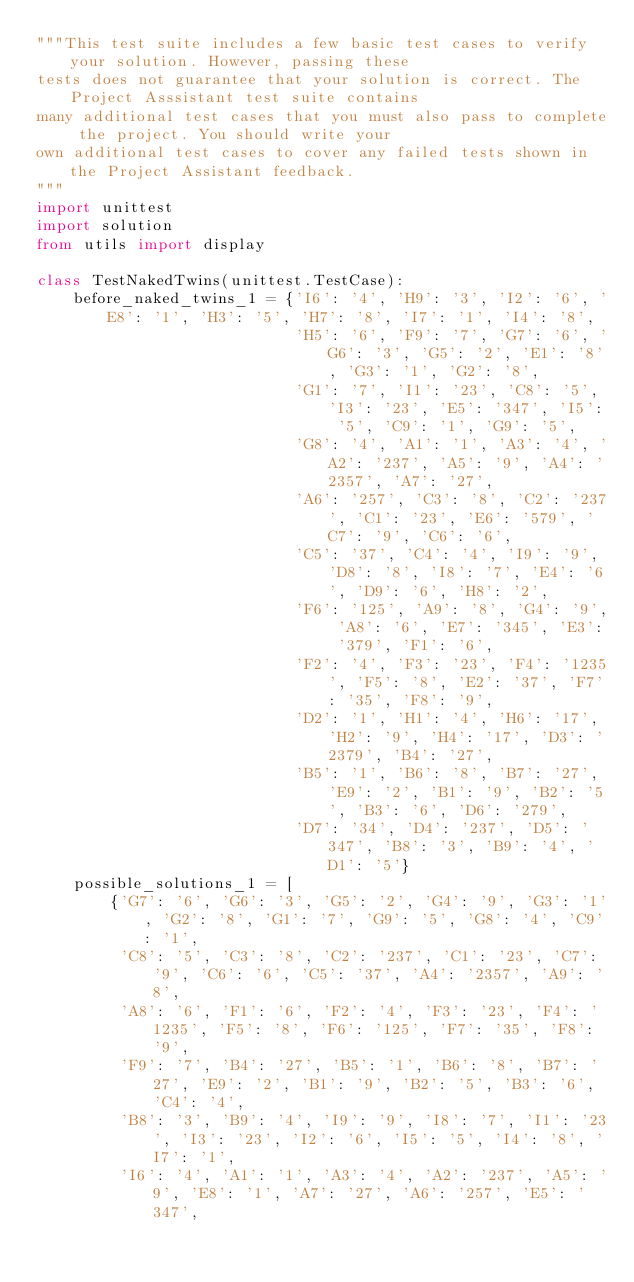<code> <loc_0><loc_0><loc_500><loc_500><_Python_>"""This test suite includes a few basic test cases to verify your solution. However, passing these
tests does not guarantee that your solution is correct. The Project Asssistant test suite contains
many additional test cases that you must also pass to complete the project. You should write your
own additional test cases to cover any failed tests shown in the Project Assistant feedback.
"""
import unittest
import solution
from utils import display

class TestNakedTwins(unittest.TestCase):
    before_naked_twins_1 = {'I6': '4', 'H9': '3', 'I2': '6', 'E8': '1', 'H3': '5', 'H7': '8', 'I7': '1', 'I4': '8',
                            'H5': '6', 'F9': '7', 'G7': '6', 'G6': '3', 'G5': '2', 'E1': '8', 'G3': '1', 'G2': '8',
                            'G1': '7', 'I1': '23', 'C8': '5', 'I3': '23', 'E5': '347', 'I5': '5', 'C9': '1', 'G9': '5',
                            'G8': '4', 'A1': '1', 'A3': '4', 'A2': '237', 'A5': '9', 'A4': '2357', 'A7': '27',
                            'A6': '257', 'C3': '8', 'C2': '237', 'C1': '23', 'E6': '579', 'C7': '9', 'C6': '6',
                            'C5': '37', 'C4': '4', 'I9': '9', 'D8': '8', 'I8': '7', 'E4': '6', 'D9': '6', 'H8': '2',
                            'F6': '125', 'A9': '8', 'G4': '9', 'A8': '6', 'E7': '345', 'E3': '379', 'F1': '6',
                            'F2': '4', 'F3': '23', 'F4': '1235', 'F5': '8', 'E2': '37', 'F7': '35', 'F8': '9',
                            'D2': '1', 'H1': '4', 'H6': '17', 'H2': '9', 'H4': '17', 'D3': '2379', 'B4': '27',
                            'B5': '1', 'B6': '8', 'B7': '27', 'E9': '2', 'B1': '9', 'B2': '5', 'B3': '6', 'D6': '279',
                            'D7': '34', 'D4': '237', 'D5': '347', 'B8': '3', 'B9': '4', 'D1': '5'}
    possible_solutions_1 = [
        {'G7': '6', 'G6': '3', 'G5': '2', 'G4': '9', 'G3': '1', 'G2': '8', 'G1': '7', 'G9': '5', 'G8': '4', 'C9': '1',
         'C8': '5', 'C3': '8', 'C2': '237', 'C1': '23', 'C7': '9', 'C6': '6', 'C5': '37', 'A4': '2357', 'A9': '8',
         'A8': '6', 'F1': '6', 'F2': '4', 'F3': '23', 'F4': '1235', 'F5': '8', 'F6': '125', 'F7': '35', 'F8': '9',
         'F9': '7', 'B4': '27', 'B5': '1', 'B6': '8', 'B7': '27', 'E9': '2', 'B1': '9', 'B2': '5', 'B3': '6', 'C4': '4',
         'B8': '3', 'B9': '4', 'I9': '9', 'I8': '7', 'I1': '23', 'I3': '23', 'I2': '6', 'I5': '5', 'I4': '8', 'I7': '1',
         'I6': '4', 'A1': '1', 'A3': '4', 'A2': '237', 'A5': '9', 'E8': '1', 'A7': '27', 'A6': '257', 'E5': '347',</code> 